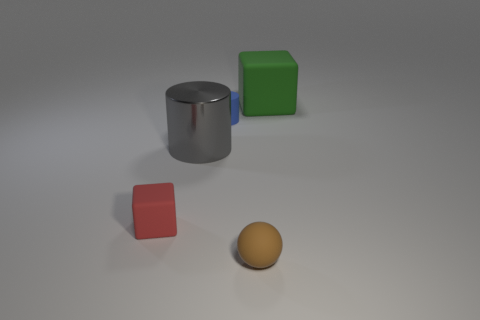Add 4 large cyan metallic cylinders. How many objects exist? 9 Subtract all balls. How many objects are left? 4 Add 5 green cubes. How many green cubes are left? 6 Add 5 blue matte cylinders. How many blue matte cylinders exist? 6 Subtract 0 purple cubes. How many objects are left? 5 Subtract all cylinders. Subtract all small brown balls. How many objects are left? 2 